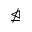<formula> <loc_0><loc_0><loc_500><loc_500>\ntrianglerighteq</formula> 